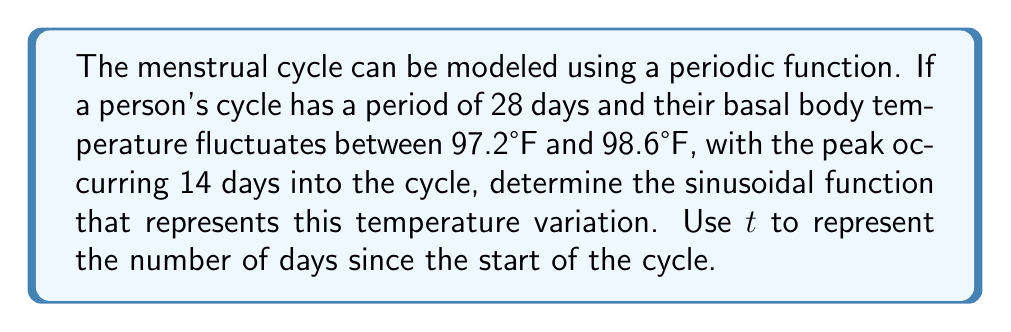Show me your answer to this math problem. Let's approach this step-by-step:

1) The general form of a sinusoidal function is:
   $$ f(t) = A \sin(B(t-C)) + D $$
   where $A$ is the amplitude, $B$ is the angular frequency, $C$ is the phase shift, and $D$ is the vertical shift.

2) Find the amplitude $A$:
   $A = \frac{\text{max} - \text{min}}{2} = \frac{98.6 - 97.2}{2} = 0.7$

3) Find the vertical shift $D$:
   $D = \frac{\text{max} + \text{min}}{2} = \frac{98.6 + 97.2}{2} = 97.9$

4) Calculate the angular frequency $B$:
   Period $= 28$ days, so $B = \frac{2\pi}{\text{period}} = \frac{2\pi}{28} = \frac{\pi}{14}$

5) Find the phase shift $C$:
   The peak occurs at day 14, which is $\frac{1}{4}$ of the way through the cycle.
   For a sine function, this corresponds to a phase shift of $\frac{3\pi}{2}$ radians.
   So, $C = \frac{3\pi}{2} \cdot \frac{14}{\pi} = 21$

6) Putting it all together:
   $$ f(t) = 0.7 \sin(\frac{\pi}{14}(t-21)) + 97.9 $$
Answer: $f(t) = 0.7 \sin(\frac{\pi}{14}(t-21)) + 97.9$ 